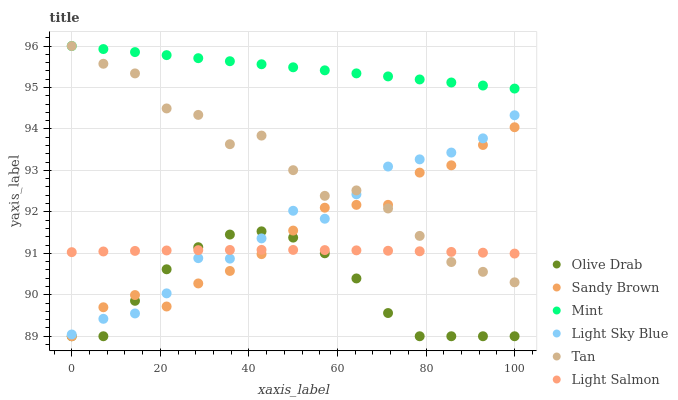Does Olive Drab have the minimum area under the curve?
Answer yes or no. Yes. Does Mint have the maximum area under the curve?
Answer yes or no. Yes. Does Sandy Brown have the minimum area under the curve?
Answer yes or no. No. Does Sandy Brown have the maximum area under the curve?
Answer yes or no. No. Is Mint the smoothest?
Answer yes or no. Yes. Is Tan the roughest?
Answer yes or no. Yes. Is Sandy Brown the smoothest?
Answer yes or no. No. Is Sandy Brown the roughest?
Answer yes or no. No. Does Sandy Brown have the lowest value?
Answer yes or no. Yes. Does Light Sky Blue have the lowest value?
Answer yes or no. No. Does Mint have the highest value?
Answer yes or no. Yes. Does Sandy Brown have the highest value?
Answer yes or no. No. Is Olive Drab less than Tan?
Answer yes or no. Yes. Is Tan greater than Olive Drab?
Answer yes or no. Yes. Does Olive Drab intersect Light Salmon?
Answer yes or no. Yes. Is Olive Drab less than Light Salmon?
Answer yes or no. No. Is Olive Drab greater than Light Salmon?
Answer yes or no. No. Does Olive Drab intersect Tan?
Answer yes or no. No. 